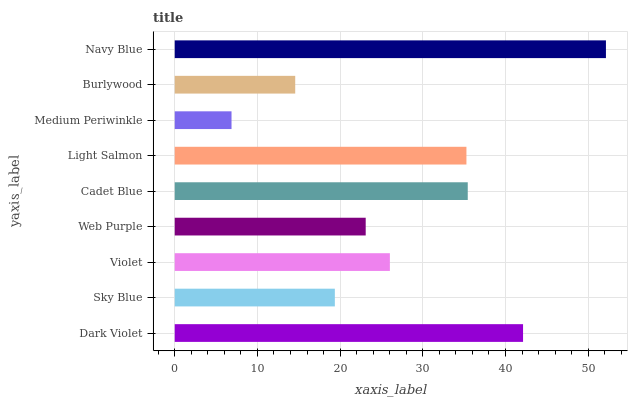Is Medium Periwinkle the minimum?
Answer yes or no. Yes. Is Navy Blue the maximum?
Answer yes or no. Yes. Is Sky Blue the minimum?
Answer yes or no. No. Is Sky Blue the maximum?
Answer yes or no. No. Is Dark Violet greater than Sky Blue?
Answer yes or no. Yes. Is Sky Blue less than Dark Violet?
Answer yes or no. Yes. Is Sky Blue greater than Dark Violet?
Answer yes or no. No. Is Dark Violet less than Sky Blue?
Answer yes or no. No. Is Violet the high median?
Answer yes or no. Yes. Is Violet the low median?
Answer yes or no. Yes. Is Medium Periwinkle the high median?
Answer yes or no. No. Is Medium Periwinkle the low median?
Answer yes or no. No. 